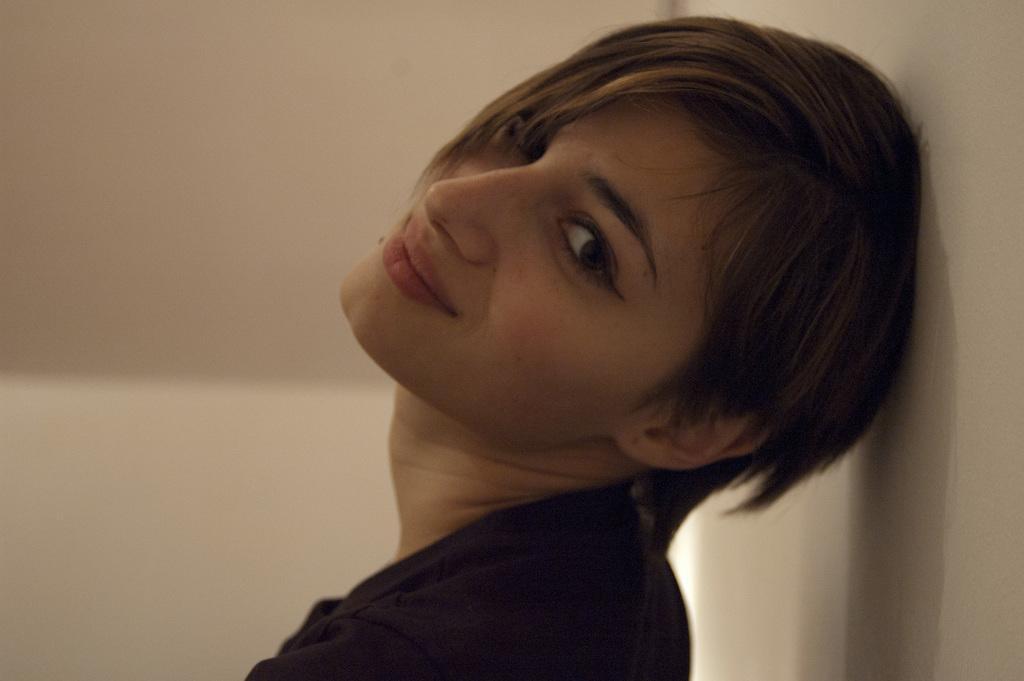In one or two sentences, can you explain what this image depicts? Here I can see a person facing towards left side, smiling and looking at the picture. On the right side there is a wall. 